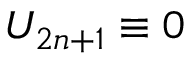<formula> <loc_0><loc_0><loc_500><loc_500>U _ { 2 n + 1 } \equiv 0</formula> 